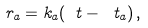<formula> <loc_0><loc_0><loc_500><loc_500>\ r _ { a } = k _ { a } ( \ t - \ t _ { a } ) \, ,</formula> 